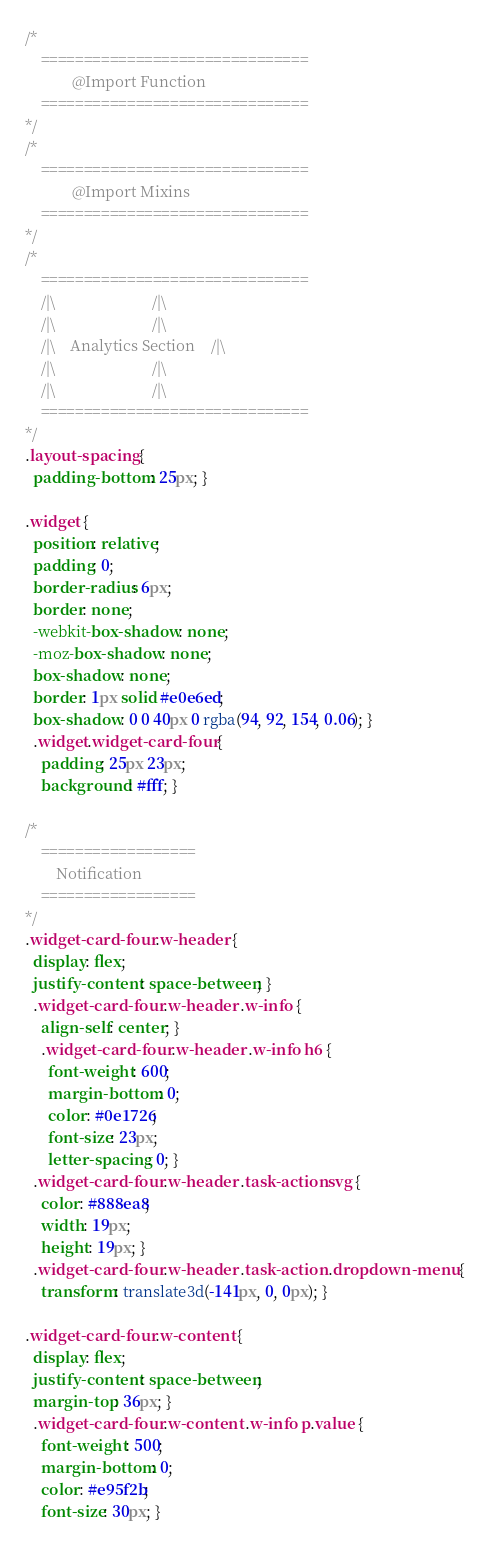Convert code to text. <code><loc_0><loc_0><loc_500><loc_500><_CSS_>/*
	===============================
			@Import	Function
	===============================
*/
/*
	===============================
			@Import	Mixins
	===============================
*/
/*
    ===============================
    /|\                         /|\
    /|\                         /|\
    /|\    Analytics Section    /|\
    /|\                         /|\
    /|\                         /|\
    ===============================
*/
.layout-spacing {
  padding-bottom: 25px; }

.widget {
  position: relative;
  padding: 0;
  border-radius: 6px;
  border: none;
  -webkit-box-shadow: none;
  -moz-box-shadow: none;
  box-shadow: none;
  border: 1px solid #e0e6ed;
  box-shadow: 0 0 40px 0 rgba(94, 92, 154, 0.06); }
  .widget.widget-card-four {
    padding: 25px 23px;
    background: #fff; }

/*
    ==================
        Notification
    ==================
*/
.widget-card-four .w-header {
  display: flex;
  justify-content: space-between; }
  .widget-card-four .w-header .w-info {
    align-self: center; }
    .widget-card-four .w-header .w-info h6 {
      font-weight: 600;
      margin-bottom: 0;
      color: #0e1726;
      font-size: 23px;
      letter-spacing: 0; }
  .widget-card-four .w-header .task-action svg {
    color: #888ea8;
    width: 19px;
    height: 19px; }
  .widget-card-four .w-header .task-action .dropdown-menu {
    transform: translate3d(-141px, 0, 0px); }

.widget-card-four .w-content {
  display: flex;
  justify-content: space-between;
  margin-top: 36px; }
  .widget-card-four .w-content .w-info p.value {
    font-weight: 500;
    margin-bottom: 0;
    color: #e95f2b;
    font-size: 30px; }</code> 